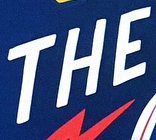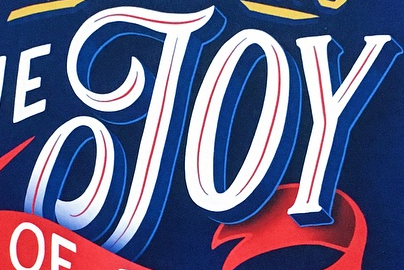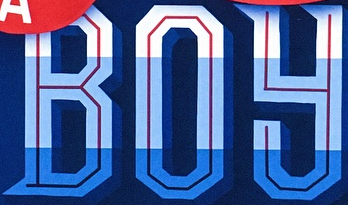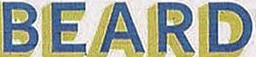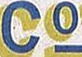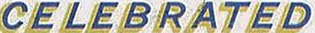Read the text content from these images in order, separated by a semicolon. THE; JOY; BOY; BEARD; Co; CELEBRATED 